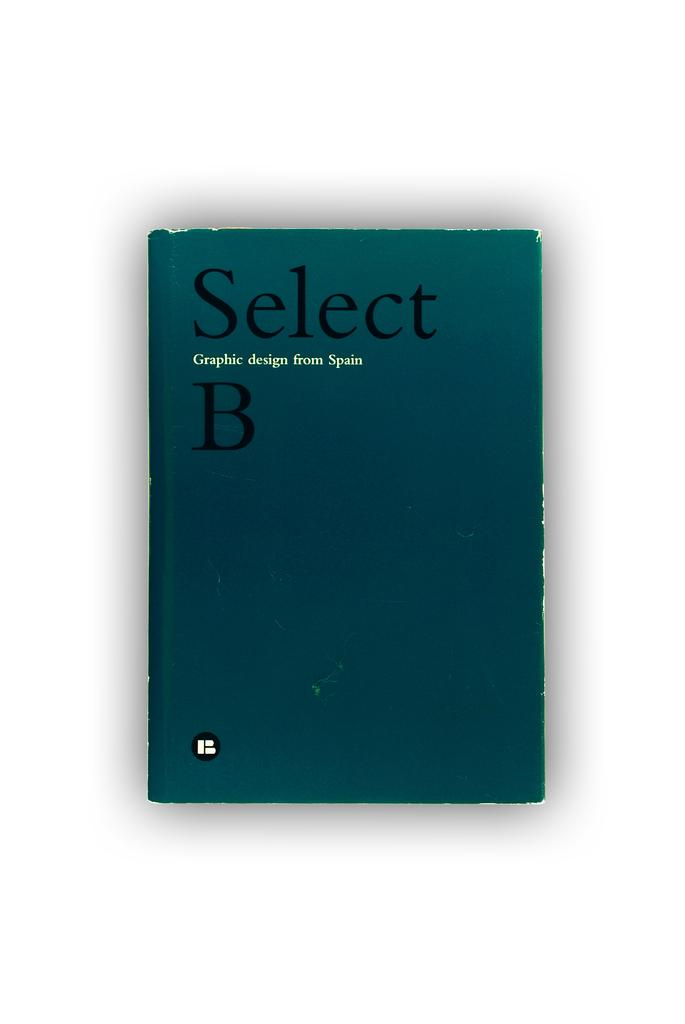Provide a one-sentence caption for the provided image. Select B Graphic design from Spain booklet that is blue. 